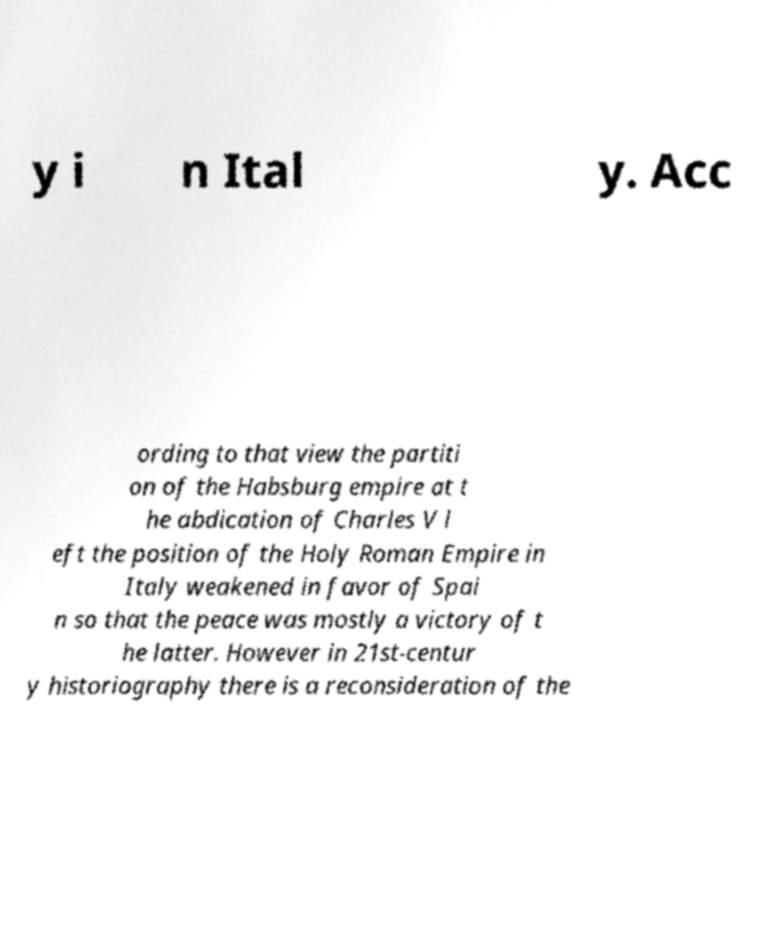Can you accurately transcribe the text from the provided image for me? y i n Ital y. Acc ording to that view the partiti on of the Habsburg empire at t he abdication of Charles V l eft the position of the Holy Roman Empire in Italy weakened in favor of Spai n so that the peace was mostly a victory of t he latter. However in 21st-centur y historiography there is a reconsideration of the 